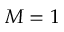Convert formula to latex. <formula><loc_0><loc_0><loc_500><loc_500>M = 1</formula> 